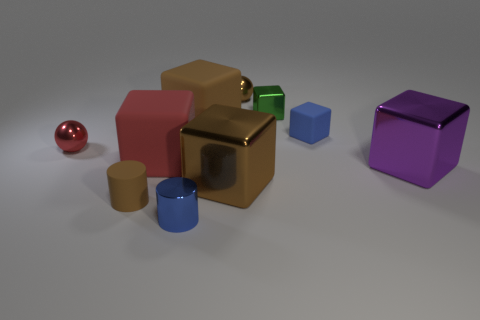There is a brown sphere that is made of the same material as the tiny blue cylinder; what size is it?
Your response must be concise. Small. There is a rubber cube that is to the right of the small green object; what number of small rubber objects are in front of it?
Provide a succinct answer. 1. Is there a cyan object that has the same shape as the purple thing?
Offer a terse response. No. The rubber thing that is in front of the big shiny block to the right of the tiny brown shiny ball is what color?
Offer a very short reply. Brown. Are there more big red matte cubes than balls?
Give a very brief answer. No. How many red matte cubes have the same size as the matte cylinder?
Your answer should be very brief. 0. Do the small red object and the sphere to the right of the small metal cylinder have the same material?
Offer a terse response. Yes. Are there fewer blue cylinders than small brown matte blocks?
Keep it short and to the point. No. Is there any other thing that is the same color as the rubber cylinder?
Provide a short and direct response. Yes. There is a small blue object that is made of the same material as the red sphere; what is its shape?
Keep it short and to the point. Cylinder. 